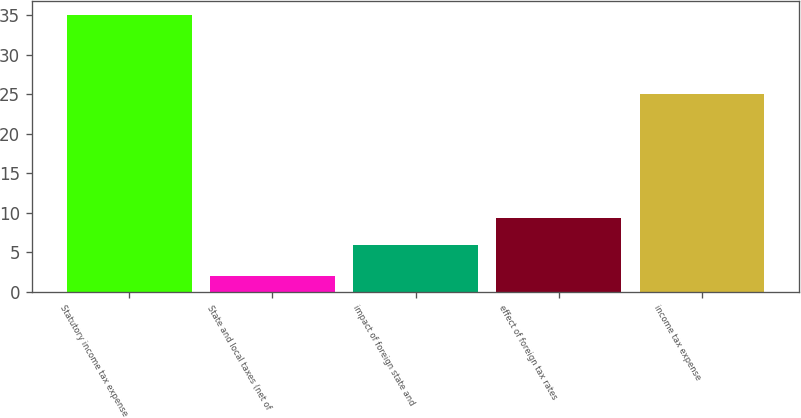Convert chart to OTSL. <chart><loc_0><loc_0><loc_500><loc_500><bar_chart><fcel>Statutory income tax expense<fcel>State and local taxes (net of<fcel>impact of foreign state and<fcel>effect of foreign tax rates<fcel>income tax expense<nl><fcel>35<fcel>2<fcel>6<fcel>9.3<fcel>25<nl></chart> 